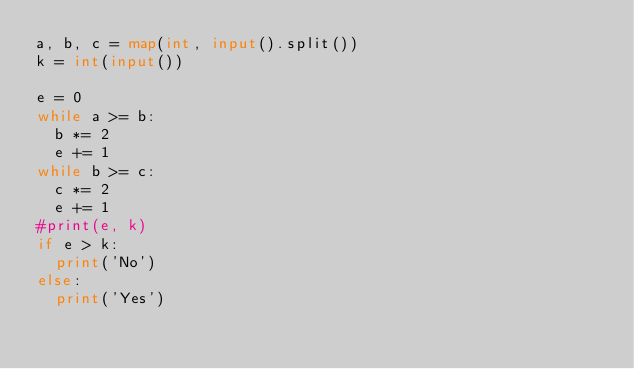<code> <loc_0><loc_0><loc_500><loc_500><_Python_>a, b, c = map(int, input().split())
k = int(input())

e = 0
while a >= b:
  b *= 2
  e += 1
while b >= c:
  c *= 2
  e += 1
#print(e, k)
if e > k:
  print('No')
else:
  print('Yes')</code> 